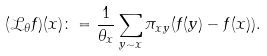Convert formula to latex. <formula><loc_0><loc_0><loc_500><loc_500>( \mathcal { L } _ { \theta } f ) ( x ) \colon = \frac { 1 } { \theta _ { x } } \sum _ { y \sim x } \pi _ { x y } ( f ( y ) - f ( x ) ) .</formula> 